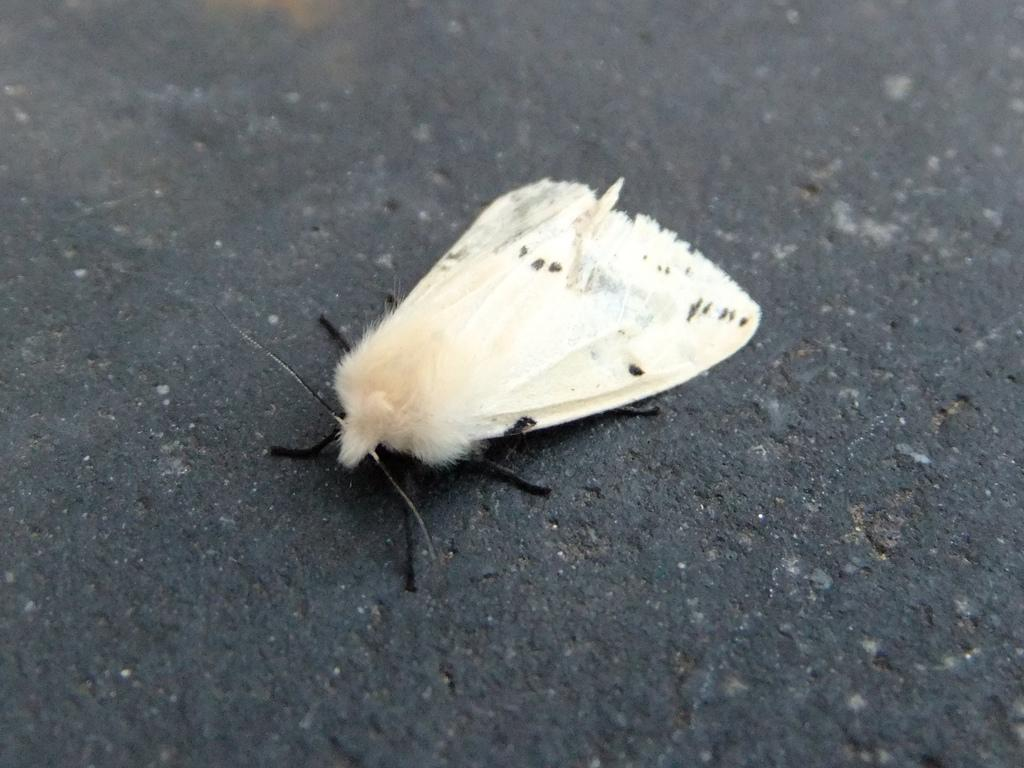What type of creature is in the image? There is an insect in the image. What is the color of the surface where the insect is located? The insect is on a black surface. Where is the insect positioned in the image? The insect is located in the center of the image. What type of jam is mentioned in the caption of the image? There is no caption present in the image, and therefore no mention of jam. 